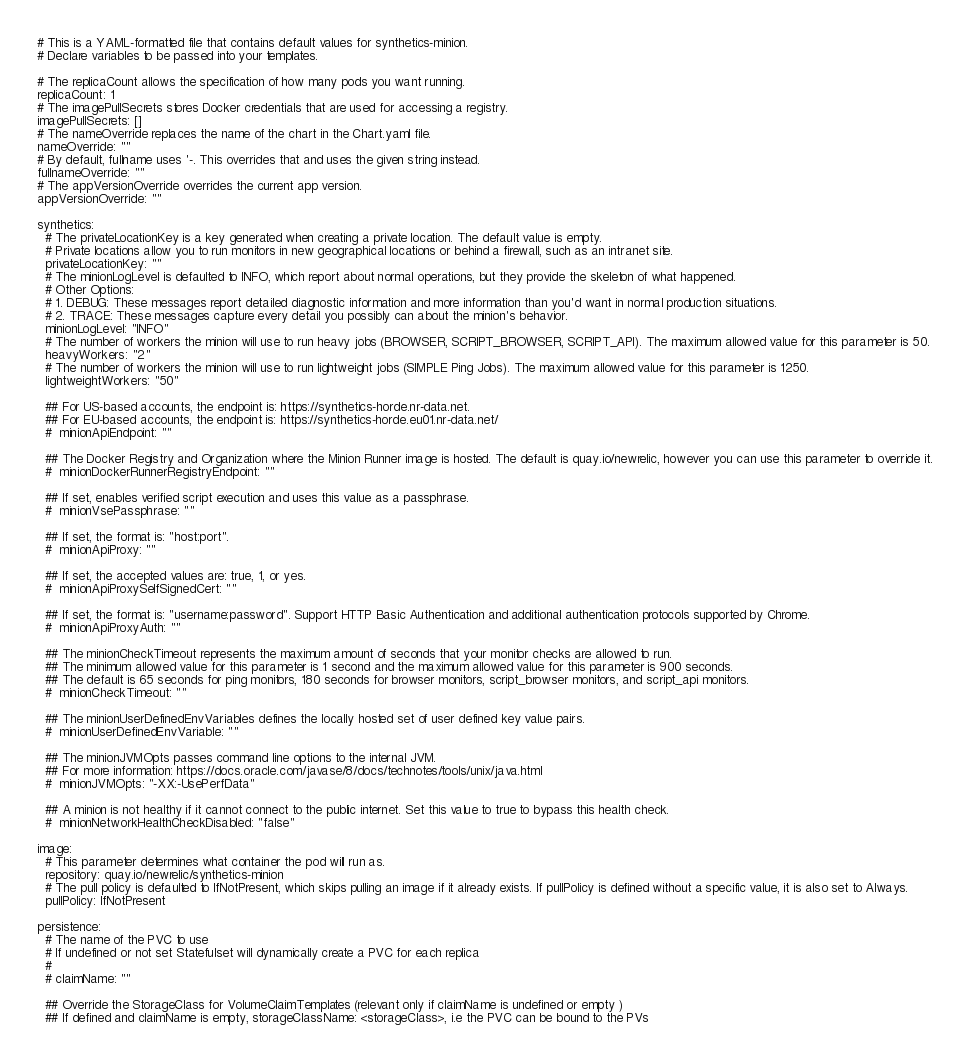Convert code to text. <code><loc_0><loc_0><loc_500><loc_500><_YAML_># This is a YAML-formatted file that contains default values for synthetics-minion.
# Declare variables to be passed into your templates.

# The replicaCount allows the specification of how many pods you want running.
replicaCount: 1
# The imagePullSecrets stores Docker credentials that are used for accessing a registry.
imagePullSecrets: []
# The nameOverride replaces the name of the chart in the Chart.yaml file.
nameOverride: ""
# By default, fullname uses '-. This overrides that and uses the given string instead.
fullnameOverride: ""
# The appVersionOverride overrides the current app version.
appVersionOverride: ""

synthetics:
  # The privateLocationKey is a key generated when creating a private location. The default value is empty.
  # Private locations allow you to run monitors in new geographical locations or behind a firewall, such as an intranet site.
  privateLocationKey: ""
  # The minionLogLevel is defaulted to INFO, which report about normal operations, but they provide the skeleton of what happened.
  # Other Options:
  # 1. DEBUG: These messages report detailed diagnostic information and more information than you'd want in normal production situations.
  # 2. TRACE: These messages capture every detail you possibly can about the minion's behavior.
  minionLogLevel: "INFO"
  # The number of workers the minion will use to run heavy jobs (BROWSER, SCRIPT_BROWSER, SCRIPT_API). The maximum allowed value for this parameter is 50.
  heavyWorkers: "2"
  # The number of workers the minion will use to run lightweight jobs (SIMPLE Ping Jobs). The maximum allowed value for this parameter is 1250.
  lightweightWorkers: "50"

  ## For US-based accounts, the endpoint is: https://synthetics-horde.nr-data.net.
  ## For EU-based accounts, the endpoint is: https://synthetics-horde.eu01.nr-data.net/
  #  minionApiEndpoint: ""

  ## The Docker Registry and Organization where the Minion Runner image is hosted. The default is quay.io/newrelic, however you can use this parameter to override it.
  #  minionDockerRunnerRegistryEndpoint: ""

  ## If set, enables verified script execution and uses this value as a passphrase.
  #  minionVsePassphrase: ""

  ## If set, the format is: "host:port".
  #  minionApiProxy: ""

  ## If set, the accepted values are: true, 1, or yes.
  #  minionApiProxySelfSignedCert: ""

  ## If set, the format is: "username:password". Support HTTP Basic Authentication and additional authentication protocols supported by Chrome.
  #  minionApiProxyAuth: ""

  ## The minionCheckTimeout represents the maximum amount of seconds that your monitor checks are allowed to run.
  ## The minimum allowed value for this parameter is 1 second and the maximum allowed value for this parameter is 900 seconds.
  ## The default is 65 seconds for ping monitors, 180 seconds for browser monitors, script_browser monitors, and script_api monitors.
  #  minionCheckTimeout: ""

  ## The minionUserDefinedEnvVariables defines the locally hosted set of user defined key value pairs.
  #  minionUserDefinedEnvVariable: ""

  ## The minionJVMOpts passes command line options to the internal JVM.
  ## For more information: https://docs.oracle.com/javase/8/docs/technotes/tools/unix/java.html
  #  minionJVMOpts: "-XX:-UsePerfData"

  ## A minion is not healthy if it cannot connect to the public internet. Set this value to true to bypass this health check.
  #  minionNetworkHealthCheckDisabled: "false"

image:
  # This parameter determines what container the pod will run as.
  repository: quay.io/newrelic/synthetics-minion
  # The pull policy is defaulted to IfNotPresent, which skips pulling an image if it already exists. If pullPolicy is defined without a specific value, it is also set to Always.
  pullPolicy: IfNotPresent

persistence:
  # The name of the PVC to use
  # If undefined or not set Statefulset will dynamically create a PVC for each replica
  #
  # claimName: ""

  ## Override the StorageClass for VolumeClaimTemplates (relevant only if claimName is undefined or empty )
  ## If defined and claimName is empty, storageClassName: <storageClass>, i.e the PVC can be bound to the PVs</code> 